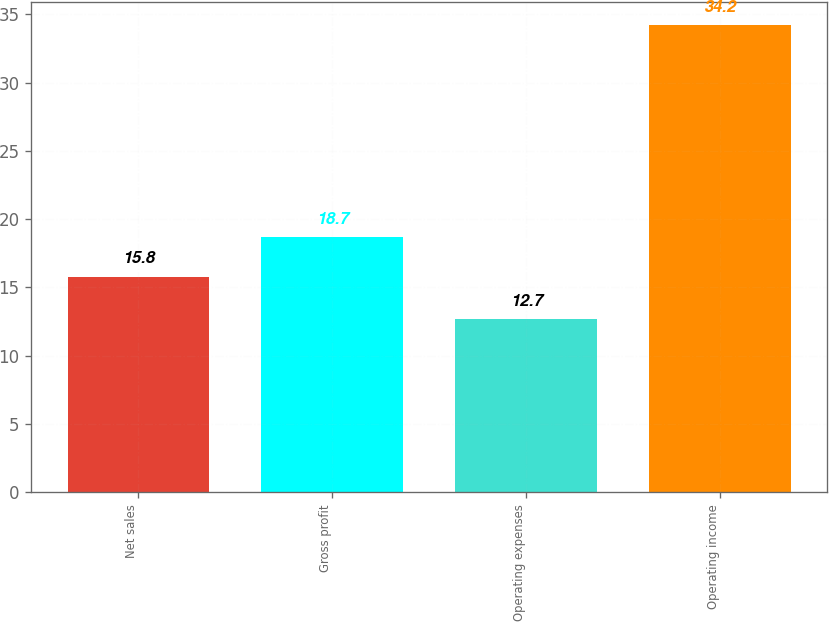<chart> <loc_0><loc_0><loc_500><loc_500><bar_chart><fcel>Net sales<fcel>Gross profit<fcel>Operating expenses<fcel>Operating income<nl><fcel>15.8<fcel>18.7<fcel>12.7<fcel>34.2<nl></chart> 